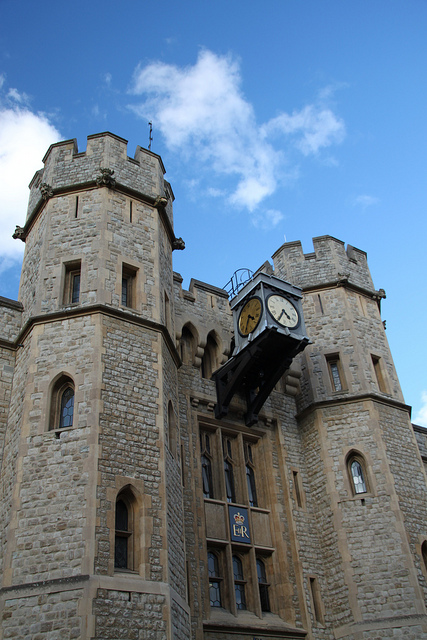Please transcribe the text in this image. R 